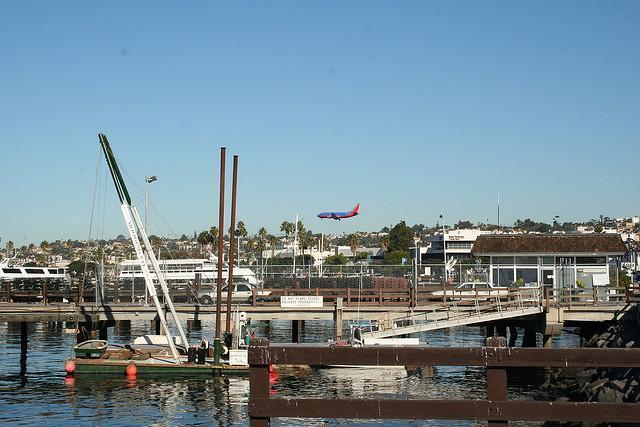How many people are shown?
Give a very brief answer. 0. 